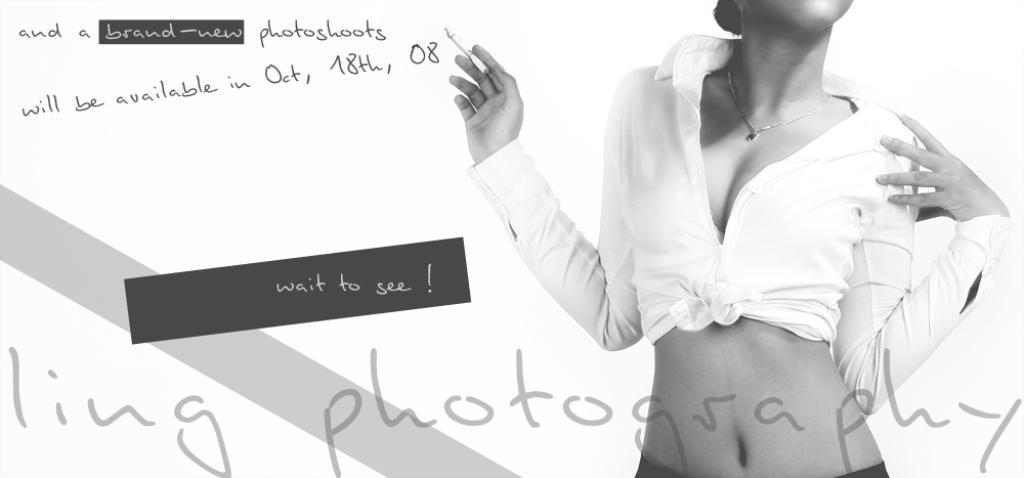Please provide a concise description of this image. This is an edited image and this is also a black and white image. In this image, on the right side, we can see a person. On the left side, we can also see some text written on it. 